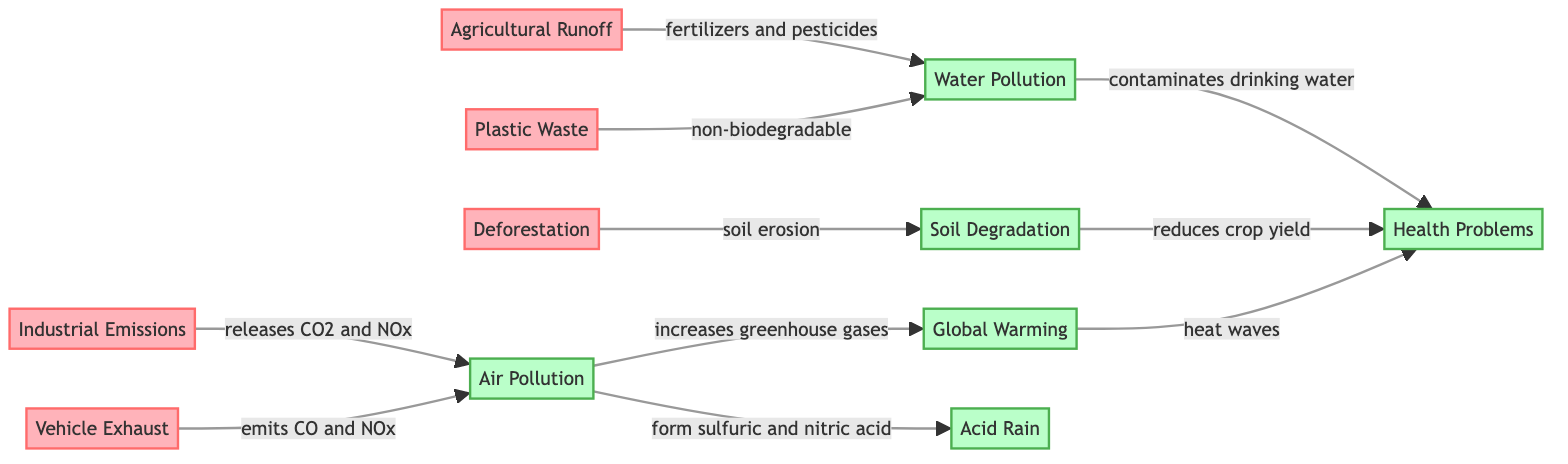What are two examples of pollutants in the diagram? The diagram identifies five pollutants, but two examples are Industrial Emissions and Vehicle Exhaust, which are both categorized as causes.
Answer: Industrial Emissions, Vehicle Exhaust How many effects are listed in the diagram? In the diagram, there are six effects shown, which are Air Pollution, Water Pollution, Soil Degradation, Global Warming, Acid Rain, and Health Problems.
Answer: 6 What does Agricultural Runoff lead to? According to the diagram, Agricultural Runoff leads to Water Pollution through the use of fertilizers and pesticides.
Answer: Water Pollution Which cause is linked to Soil Degradation? The diagram shows that Deforestation is linked to Soil Degradation due to soil erosion, making it a direct cause for this effect.
Answer: Deforestation How does Air Pollution contribute to Health Problems? The diagram indicates that Air Pollution contaminates drinking water, which leads to Health Problems, revealing a direct relationship between these two nodes.
Answer: contaminates drinking water What does Plastic Waste cause according to the diagram? The diagram describes that Plastic Waste does not biodegrade and is connected to Water Pollution, indicating its environmental impact.
Answer: Water Pollution Which effect is connected to Global Warming? Global Warming is linked to Health Problems through heat waves, as shown in the diagram, revealing a direct consequence of rising global temperatures.
Answer: Health Problems How many causes link to Air Pollution? There are two causes that link to Air Pollution: Industrial Emissions and Vehicle Exhaust as shown by the arrows pointing towards the Air Pollution effect in the diagram.
Answer: 2 